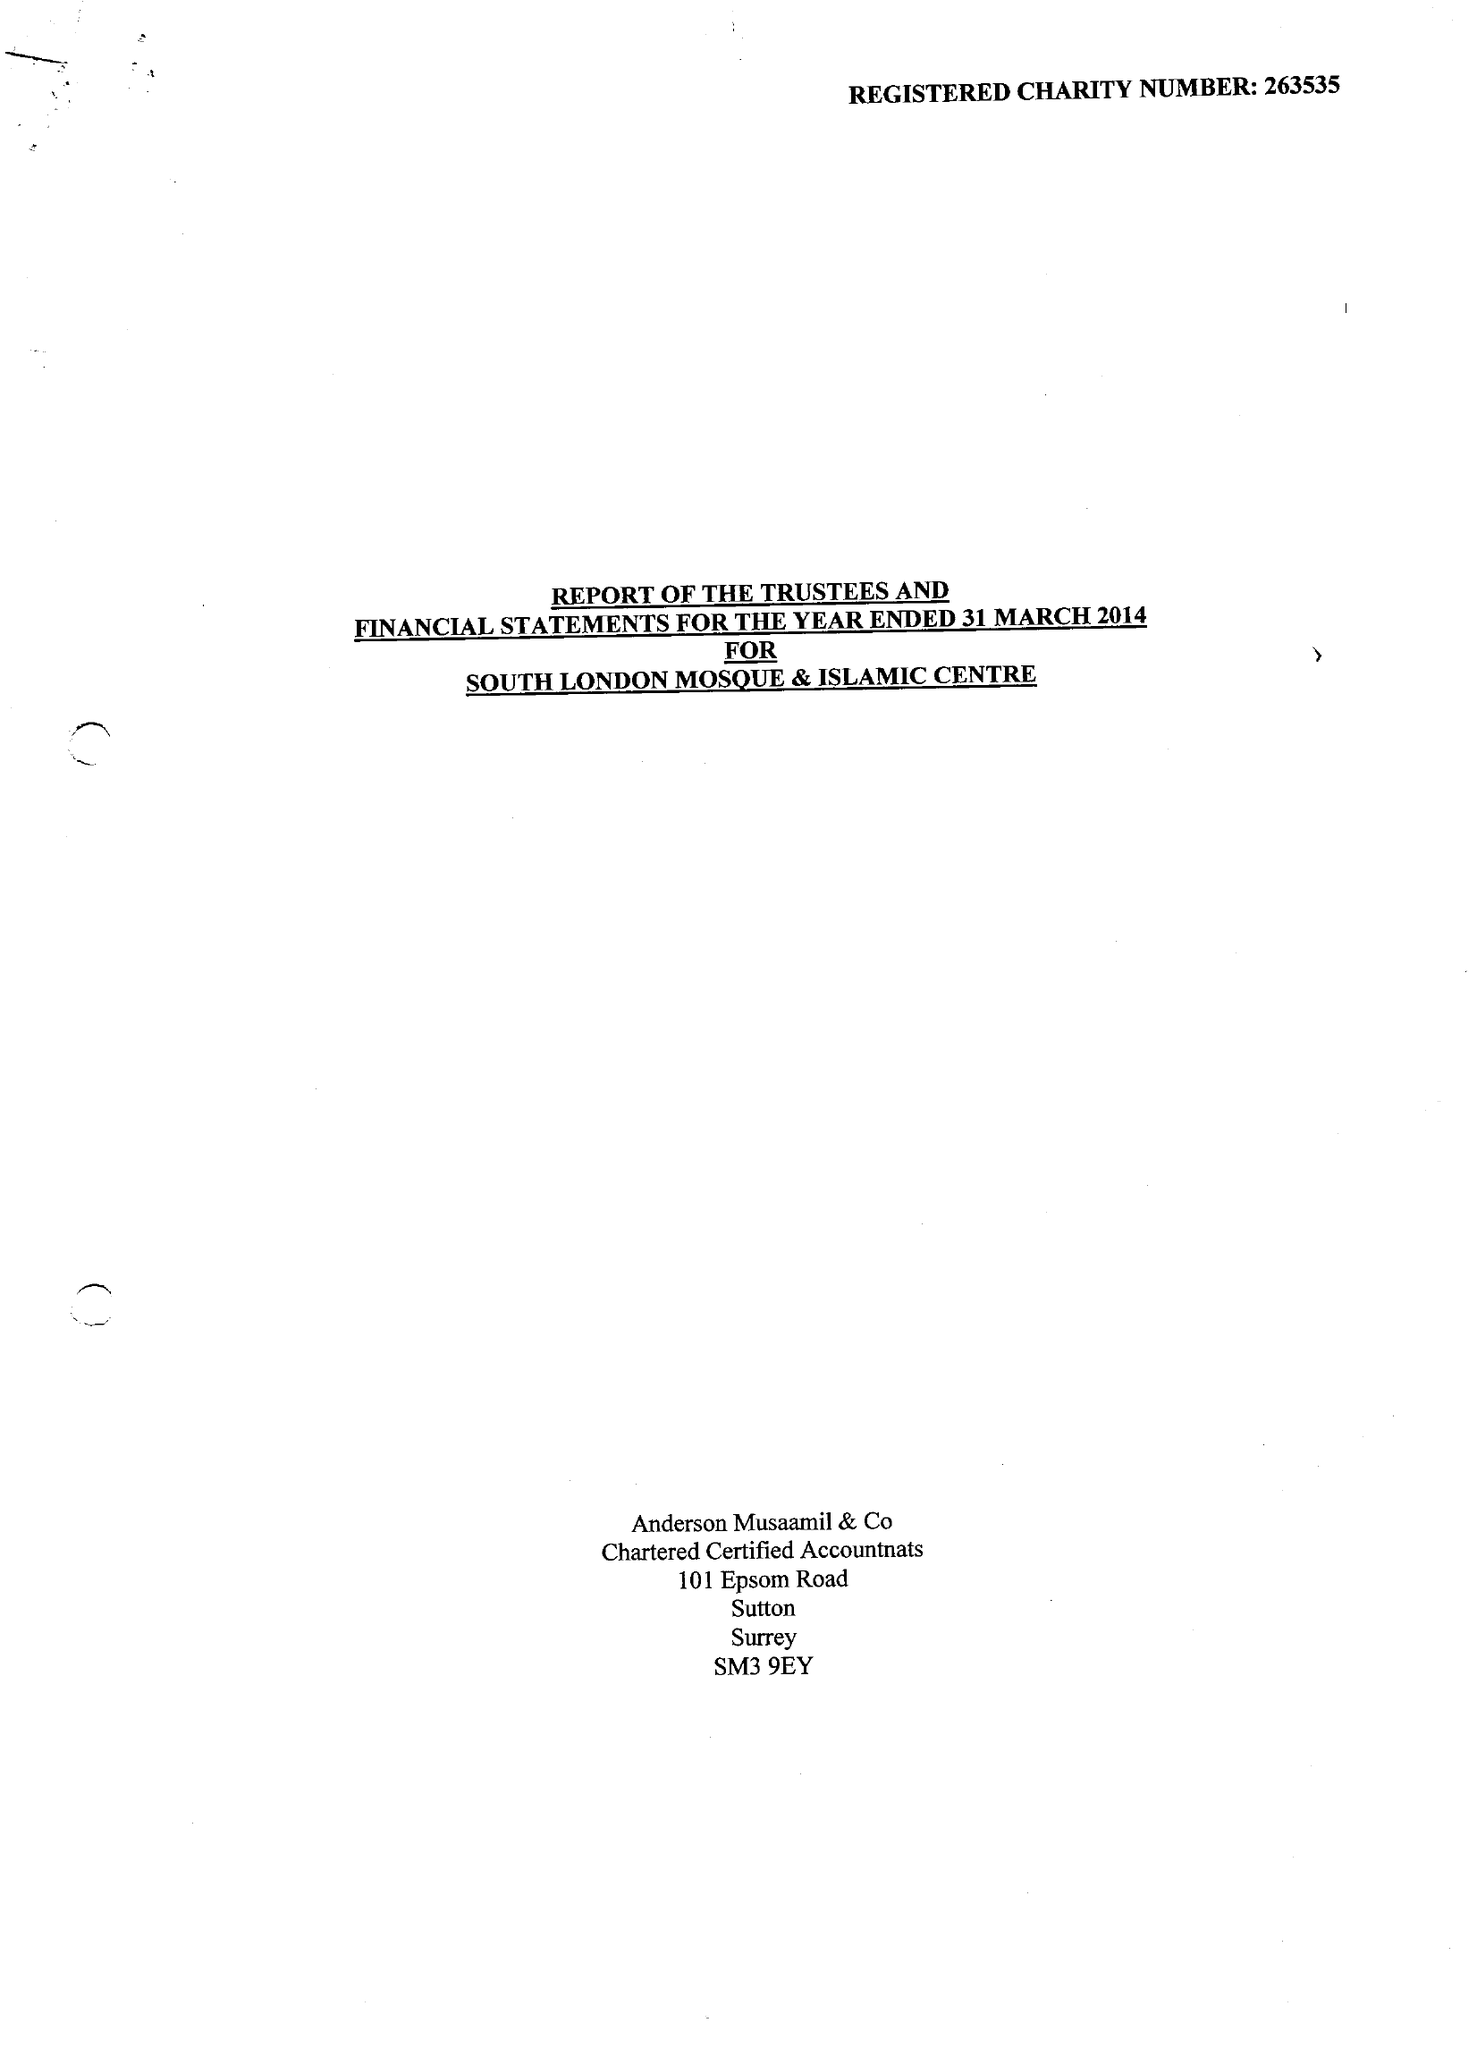What is the value for the address__post_town?
Answer the question using a single word or phrase. LONDON 